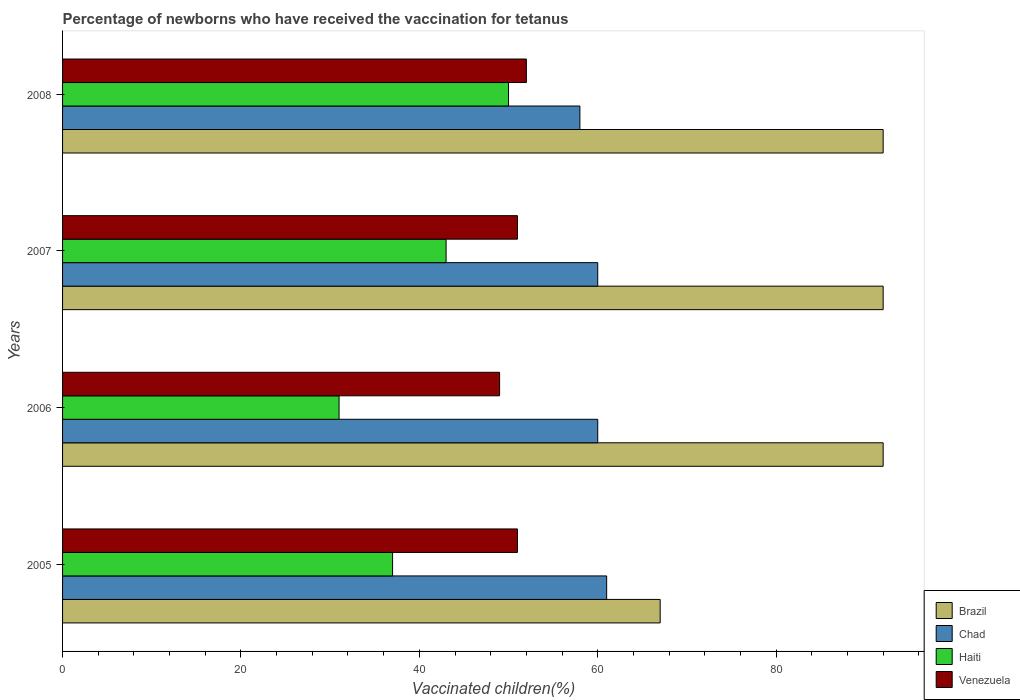How many groups of bars are there?
Provide a succinct answer. 4. Are the number of bars per tick equal to the number of legend labels?
Your answer should be very brief. Yes. What is the label of the 4th group of bars from the top?
Give a very brief answer. 2005. What is the percentage of vaccinated children in Brazil in 2006?
Give a very brief answer. 92. In which year was the percentage of vaccinated children in Brazil maximum?
Provide a short and direct response. 2006. In which year was the percentage of vaccinated children in Haiti minimum?
Your answer should be compact. 2006. What is the total percentage of vaccinated children in Venezuela in the graph?
Ensure brevity in your answer.  203. What is the difference between the percentage of vaccinated children in Venezuela in 2005 and the percentage of vaccinated children in Brazil in 2008?
Offer a very short reply. -41. What is the average percentage of vaccinated children in Haiti per year?
Provide a short and direct response. 40.25. In the year 2006, what is the difference between the percentage of vaccinated children in Venezuela and percentage of vaccinated children in Brazil?
Make the answer very short. -43. What is the ratio of the percentage of vaccinated children in Chad in 2005 to that in 2007?
Provide a succinct answer. 1.02. Is the percentage of vaccinated children in Haiti in 2006 less than that in 2008?
Provide a short and direct response. Yes. Is the difference between the percentage of vaccinated children in Venezuela in 2007 and 2008 greater than the difference between the percentage of vaccinated children in Brazil in 2007 and 2008?
Offer a very short reply. No. What is the difference between the highest and the lowest percentage of vaccinated children in Brazil?
Your response must be concise. 25. In how many years, is the percentage of vaccinated children in Venezuela greater than the average percentage of vaccinated children in Venezuela taken over all years?
Make the answer very short. 3. Is the sum of the percentage of vaccinated children in Brazil in 2005 and 2006 greater than the maximum percentage of vaccinated children in Haiti across all years?
Provide a succinct answer. Yes. Is it the case that in every year, the sum of the percentage of vaccinated children in Brazil and percentage of vaccinated children in Chad is greater than the sum of percentage of vaccinated children in Venezuela and percentage of vaccinated children in Haiti?
Provide a short and direct response. No. What does the 1st bar from the top in 2005 represents?
Your answer should be compact. Venezuela. What does the 1st bar from the bottom in 2008 represents?
Offer a very short reply. Brazil. Is it the case that in every year, the sum of the percentage of vaccinated children in Brazil and percentage of vaccinated children in Chad is greater than the percentage of vaccinated children in Haiti?
Offer a terse response. Yes. Are all the bars in the graph horizontal?
Your answer should be compact. Yes. How many years are there in the graph?
Your answer should be very brief. 4. Where does the legend appear in the graph?
Keep it short and to the point. Bottom right. How many legend labels are there?
Make the answer very short. 4. How are the legend labels stacked?
Make the answer very short. Vertical. What is the title of the graph?
Offer a very short reply. Percentage of newborns who have received the vaccination for tetanus. Does "Israel" appear as one of the legend labels in the graph?
Make the answer very short. No. What is the label or title of the X-axis?
Offer a very short reply. Vaccinated children(%). What is the label or title of the Y-axis?
Ensure brevity in your answer.  Years. What is the Vaccinated children(%) in Brazil in 2005?
Make the answer very short. 67. What is the Vaccinated children(%) of Venezuela in 2005?
Make the answer very short. 51. What is the Vaccinated children(%) in Brazil in 2006?
Offer a terse response. 92. What is the Vaccinated children(%) of Chad in 2006?
Provide a succinct answer. 60. What is the Vaccinated children(%) in Haiti in 2006?
Offer a very short reply. 31. What is the Vaccinated children(%) of Brazil in 2007?
Your response must be concise. 92. What is the Vaccinated children(%) of Chad in 2007?
Ensure brevity in your answer.  60. What is the Vaccinated children(%) in Brazil in 2008?
Provide a succinct answer. 92. What is the Vaccinated children(%) of Chad in 2008?
Give a very brief answer. 58. What is the Vaccinated children(%) in Haiti in 2008?
Give a very brief answer. 50. What is the Vaccinated children(%) of Venezuela in 2008?
Offer a very short reply. 52. Across all years, what is the maximum Vaccinated children(%) of Brazil?
Offer a very short reply. 92. Across all years, what is the maximum Vaccinated children(%) of Chad?
Your response must be concise. 61. Across all years, what is the maximum Vaccinated children(%) of Haiti?
Keep it short and to the point. 50. Across all years, what is the minimum Vaccinated children(%) of Chad?
Your answer should be very brief. 58. Across all years, what is the minimum Vaccinated children(%) of Haiti?
Offer a terse response. 31. Across all years, what is the minimum Vaccinated children(%) of Venezuela?
Your response must be concise. 49. What is the total Vaccinated children(%) in Brazil in the graph?
Keep it short and to the point. 343. What is the total Vaccinated children(%) of Chad in the graph?
Offer a terse response. 239. What is the total Vaccinated children(%) of Haiti in the graph?
Provide a short and direct response. 161. What is the total Vaccinated children(%) in Venezuela in the graph?
Ensure brevity in your answer.  203. What is the difference between the Vaccinated children(%) in Brazil in 2005 and that in 2006?
Make the answer very short. -25. What is the difference between the Vaccinated children(%) in Chad in 2005 and that in 2006?
Keep it short and to the point. 1. What is the difference between the Vaccinated children(%) in Haiti in 2005 and that in 2006?
Give a very brief answer. 6. What is the difference between the Vaccinated children(%) in Brazil in 2005 and that in 2007?
Make the answer very short. -25. What is the difference between the Vaccinated children(%) in Haiti in 2005 and that in 2007?
Offer a very short reply. -6. What is the difference between the Vaccinated children(%) in Brazil in 2005 and that in 2008?
Keep it short and to the point. -25. What is the difference between the Vaccinated children(%) of Brazil in 2006 and that in 2007?
Offer a terse response. 0. What is the difference between the Vaccinated children(%) in Venezuela in 2006 and that in 2007?
Keep it short and to the point. -2. What is the difference between the Vaccinated children(%) in Brazil in 2006 and that in 2008?
Your answer should be compact. 0. What is the difference between the Vaccinated children(%) of Chad in 2006 and that in 2008?
Keep it short and to the point. 2. What is the difference between the Vaccinated children(%) in Brazil in 2007 and that in 2008?
Provide a succinct answer. 0. What is the difference between the Vaccinated children(%) of Chad in 2007 and that in 2008?
Offer a very short reply. 2. What is the difference between the Vaccinated children(%) in Haiti in 2007 and that in 2008?
Your answer should be compact. -7. What is the difference between the Vaccinated children(%) in Venezuela in 2007 and that in 2008?
Ensure brevity in your answer.  -1. What is the difference between the Vaccinated children(%) in Brazil in 2005 and the Vaccinated children(%) in Haiti in 2006?
Provide a short and direct response. 36. What is the difference between the Vaccinated children(%) of Haiti in 2005 and the Vaccinated children(%) of Venezuela in 2006?
Your answer should be compact. -12. What is the difference between the Vaccinated children(%) of Brazil in 2005 and the Vaccinated children(%) of Venezuela in 2007?
Give a very brief answer. 16. What is the difference between the Vaccinated children(%) in Chad in 2005 and the Vaccinated children(%) in Haiti in 2007?
Provide a succinct answer. 18. What is the difference between the Vaccinated children(%) of Chad in 2005 and the Vaccinated children(%) of Venezuela in 2007?
Ensure brevity in your answer.  10. What is the difference between the Vaccinated children(%) in Brazil in 2005 and the Vaccinated children(%) in Chad in 2008?
Make the answer very short. 9. What is the difference between the Vaccinated children(%) in Brazil in 2005 and the Vaccinated children(%) in Haiti in 2008?
Your answer should be compact. 17. What is the difference between the Vaccinated children(%) of Chad in 2005 and the Vaccinated children(%) of Haiti in 2008?
Keep it short and to the point. 11. What is the difference between the Vaccinated children(%) in Chad in 2005 and the Vaccinated children(%) in Venezuela in 2008?
Your answer should be compact. 9. What is the difference between the Vaccinated children(%) of Chad in 2006 and the Vaccinated children(%) of Haiti in 2007?
Ensure brevity in your answer.  17. What is the difference between the Vaccinated children(%) of Chad in 2006 and the Vaccinated children(%) of Venezuela in 2007?
Make the answer very short. 9. What is the difference between the Vaccinated children(%) in Brazil in 2006 and the Vaccinated children(%) in Haiti in 2008?
Your answer should be compact. 42. What is the difference between the Vaccinated children(%) of Chad in 2006 and the Vaccinated children(%) of Venezuela in 2008?
Provide a short and direct response. 8. What is the difference between the Vaccinated children(%) of Brazil in 2007 and the Vaccinated children(%) of Chad in 2008?
Ensure brevity in your answer.  34. What is the difference between the Vaccinated children(%) in Chad in 2007 and the Vaccinated children(%) in Haiti in 2008?
Give a very brief answer. 10. What is the average Vaccinated children(%) in Brazil per year?
Offer a very short reply. 85.75. What is the average Vaccinated children(%) in Chad per year?
Provide a short and direct response. 59.75. What is the average Vaccinated children(%) of Haiti per year?
Offer a very short reply. 40.25. What is the average Vaccinated children(%) in Venezuela per year?
Ensure brevity in your answer.  50.75. In the year 2005, what is the difference between the Vaccinated children(%) of Brazil and Vaccinated children(%) of Chad?
Provide a short and direct response. 6. In the year 2005, what is the difference between the Vaccinated children(%) in Brazil and Vaccinated children(%) in Haiti?
Offer a very short reply. 30. In the year 2005, what is the difference between the Vaccinated children(%) in Brazil and Vaccinated children(%) in Venezuela?
Offer a terse response. 16. In the year 2005, what is the difference between the Vaccinated children(%) of Chad and Vaccinated children(%) of Haiti?
Ensure brevity in your answer.  24. In the year 2005, what is the difference between the Vaccinated children(%) of Chad and Vaccinated children(%) of Venezuela?
Provide a succinct answer. 10. In the year 2005, what is the difference between the Vaccinated children(%) of Haiti and Vaccinated children(%) of Venezuela?
Ensure brevity in your answer.  -14. In the year 2006, what is the difference between the Vaccinated children(%) in Brazil and Vaccinated children(%) in Chad?
Offer a terse response. 32. In the year 2006, what is the difference between the Vaccinated children(%) in Brazil and Vaccinated children(%) in Haiti?
Provide a short and direct response. 61. In the year 2006, what is the difference between the Vaccinated children(%) in Brazil and Vaccinated children(%) in Venezuela?
Offer a very short reply. 43. In the year 2006, what is the difference between the Vaccinated children(%) in Chad and Vaccinated children(%) in Haiti?
Your answer should be very brief. 29. In the year 2006, what is the difference between the Vaccinated children(%) in Haiti and Vaccinated children(%) in Venezuela?
Ensure brevity in your answer.  -18. In the year 2007, what is the difference between the Vaccinated children(%) in Brazil and Vaccinated children(%) in Chad?
Give a very brief answer. 32. In the year 2007, what is the difference between the Vaccinated children(%) in Chad and Vaccinated children(%) in Venezuela?
Provide a succinct answer. 9. In the year 2007, what is the difference between the Vaccinated children(%) in Haiti and Vaccinated children(%) in Venezuela?
Offer a terse response. -8. In the year 2008, what is the difference between the Vaccinated children(%) of Brazil and Vaccinated children(%) of Venezuela?
Offer a very short reply. 40. In the year 2008, what is the difference between the Vaccinated children(%) in Chad and Vaccinated children(%) in Venezuela?
Provide a succinct answer. 6. What is the ratio of the Vaccinated children(%) in Brazil in 2005 to that in 2006?
Give a very brief answer. 0.73. What is the ratio of the Vaccinated children(%) in Chad in 2005 to that in 2006?
Ensure brevity in your answer.  1.02. What is the ratio of the Vaccinated children(%) of Haiti in 2005 to that in 2006?
Make the answer very short. 1.19. What is the ratio of the Vaccinated children(%) in Venezuela in 2005 to that in 2006?
Your response must be concise. 1.04. What is the ratio of the Vaccinated children(%) of Brazil in 2005 to that in 2007?
Your response must be concise. 0.73. What is the ratio of the Vaccinated children(%) in Chad in 2005 to that in 2007?
Your answer should be very brief. 1.02. What is the ratio of the Vaccinated children(%) of Haiti in 2005 to that in 2007?
Offer a terse response. 0.86. What is the ratio of the Vaccinated children(%) of Brazil in 2005 to that in 2008?
Make the answer very short. 0.73. What is the ratio of the Vaccinated children(%) of Chad in 2005 to that in 2008?
Ensure brevity in your answer.  1.05. What is the ratio of the Vaccinated children(%) in Haiti in 2005 to that in 2008?
Your answer should be very brief. 0.74. What is the ratio of the Vaccinated children(%) in Venezuela in 2005 to that in 2008?
Your response must be concise. 0.98. What is the ratio of the Vaccinated children(%) of Haiti in 2006 to that in 2007?
Offer a very short reply. 0.72. What is the ratio of the Vaccinated children(%) of Venezuela in 2006 to that in 2007?
Ensure brevity in your answer.  0.96. What is the ratio of the Vaccinated children(%) in Chad in 2006 to that in 2008?
Give a very brief answer. 1.03. What is the ratio of the Vaccinated children(%) in Haiti in 2006 to that in 2008?
Make the answer very short. 0.62. What is the ratio of the Vaccinated children(%) of Venezuela in 2006 to that in 2008?
Provide a short and direct response. 0.94. What is the ratio of the Vaccinated children(%) in Chad in 2007 to that in 2008?
Provide a succinct answer. 1.03. What is the ratio of the Vaccinated children(%) in Haiti in 2007 to that in 2008?
Your response must be concise. 0.86. What is the ratio of the Vaccinated children(%) of Venezuela in 2007 to that in 2008?
Provide a succinct answer. 0.98. What is the difference between the highest and the second highest Vaccinated children(%) in Chad?
Your response must be concise. 1. What is the difference between the highest and the second highest Vaccinated children(%) in Haiti?
Your answer should be compact. 7. What is the difference between the highest and the second highest Vaccinated children(%) of Venezuela?
Your answer should be compact. 1. What is the difference between the highest and the lowest Vaccinated children(%) in Venezuela?
Your answer should be very brief. 3. 